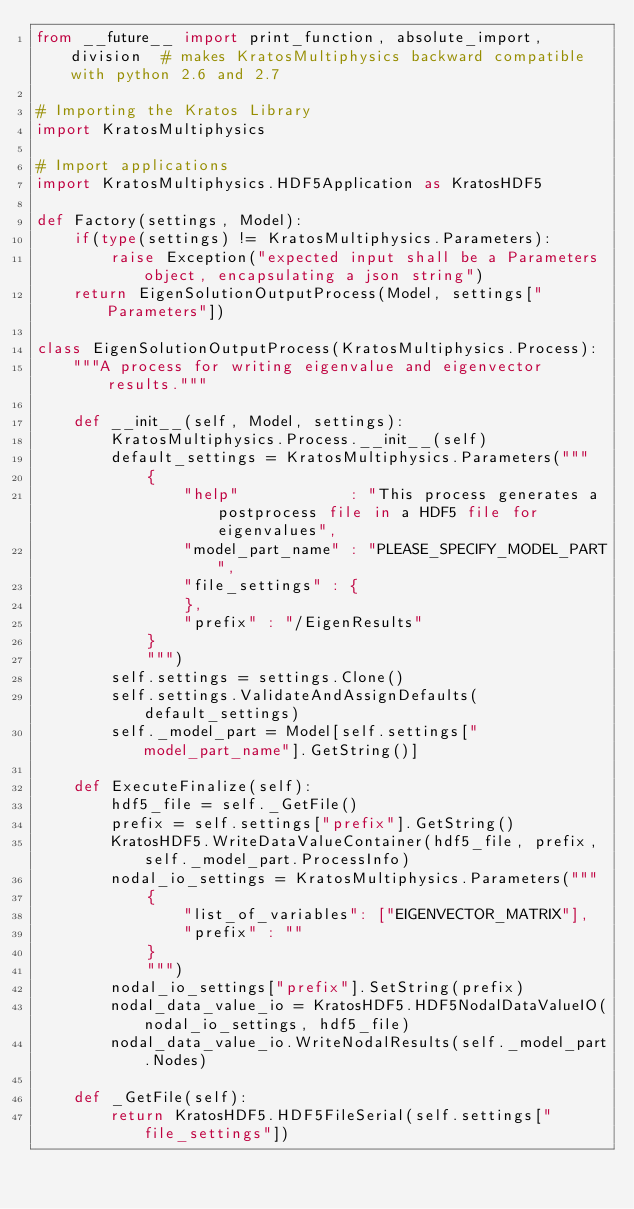<code> <loc_0><loc_0><loc_500><loc_500><_Python_>from __future__ import print_function, absolute_import, division  # makes KratosMultiphysics backward compatible with python 2.6 and 2.7

# Importing the Kratos Library
import KratosMultiphysics

# Import applications
import KratosMultiphysics.HDF5Application as KratosHDF5

def Factory(settings, Model):
    if(type(settings) != KratosMultiphysics.Parameters):
        raise Exception("expected input shall be a Parameters object, encapsulating a json string")
    return EigenSolutionOutputProcess(Model, settings["Parameters"])

class EigenSolutionOutputProcess(KratosMultiphysics.Process):
    """A process for writing eigenvalue and eigenvector results."""

    def __init__(self, Model, settings):
        KratosMultiphysics.Process.__init__(self)
        default_settings = KratosMultiphysics.Parameters("""
            {
                "help"            : "This process generates a postprocess file in a HDF5 file for eigenvalues",
                "model_part_name" : "PLEASE_SPECIFY_MODEL_PART",
                "file_settings" : {
                },
                "prefix" : "/EigenResults"
            }
            """)
        self.settings = settings.Clone()
        self.settings.ValidateAndAssignDefaults(default_settings)
        self._model_part = Model[self.settings["model_part_name"].GetString()]

    def ExecuteFinalize(self):
        hdf5_file = self._GetFile()
        prefix = self.settings["prefix"].GetString()
        KratosHDF5.WriteDataValueContainer(hdf5_file, prefix, self._model_part.ProcessInfo)
        nodal_io_settings = KratosMultiphysics.Parameters("""
            {
                "list_of_variables": ["EIGENVECTOR_MATRIX"],
                "prefix" : ""
            }
            """)
        nodal_io_settings["prefix"].SetString(prefix)
        nodal_data_value_io = KratosHDF5.HDF5NodalDataValueIO(nodal_io_settings, hdf5_file)
        nodal_data_value_io.WriteNodalResults(self._model_part.Nodes)

    def _GetFile(self):
        return KratosHDF5.HDF5FileSerial(self.settings["file_settings"])
</code> 